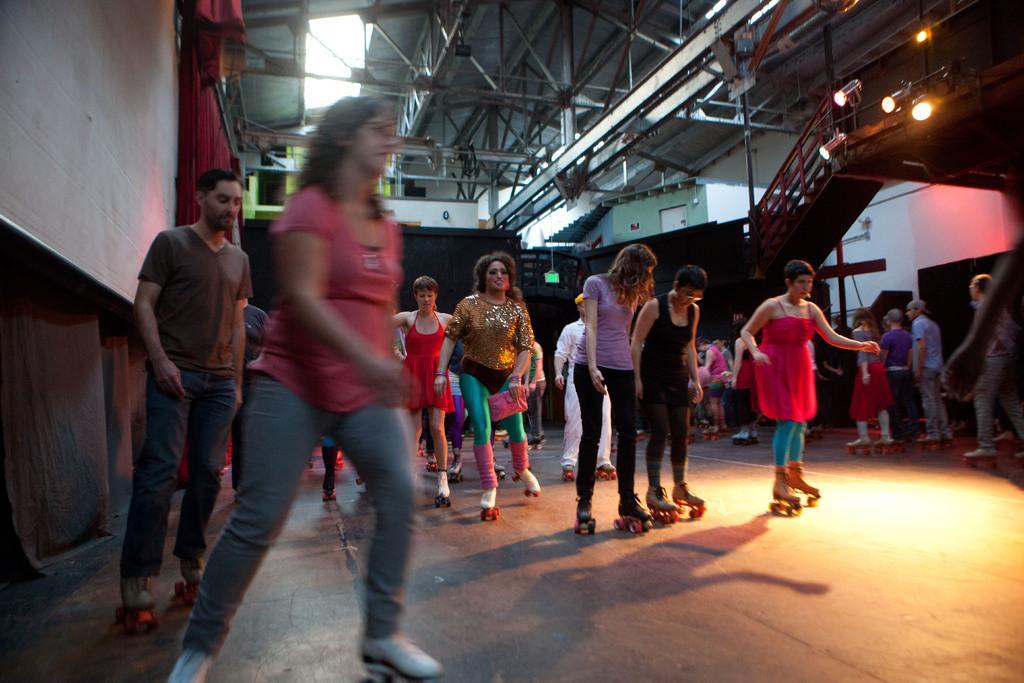How would you summarize this image in a sentence or two? In this image there are a few people skating on the floor, around them there are few objects, curtains, stairs, lights and at the top of the image there is a ceiling. 